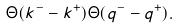<formula> <loc_0><loc_0><loc_500><loc_500>\Theta ( k ^ { - } - k ^ { + } ) \Theta ( q ^ { - } - q ^ { + } ) .</formula> 